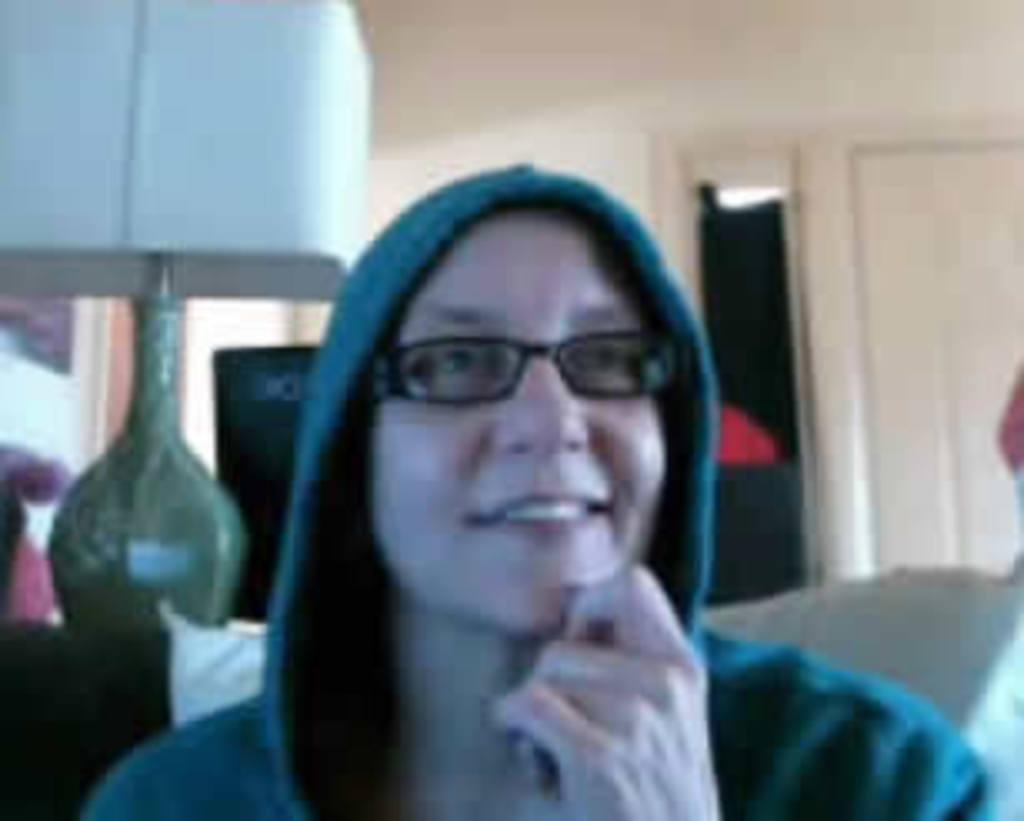Who is the main subject in the image? There is a woman in the image. What is the woman wearing on her upper body? The woman is wearing a hoodie. What accessory is the woman wearing on her face? The woman is wearing spectacles. What can be seen in the background of the image? There is a wall, a lamp light, and other objects visible in the background of the image. What type of honey is the woman holding in the image? There is no honey present in the image; the woman is not holding any honey. 